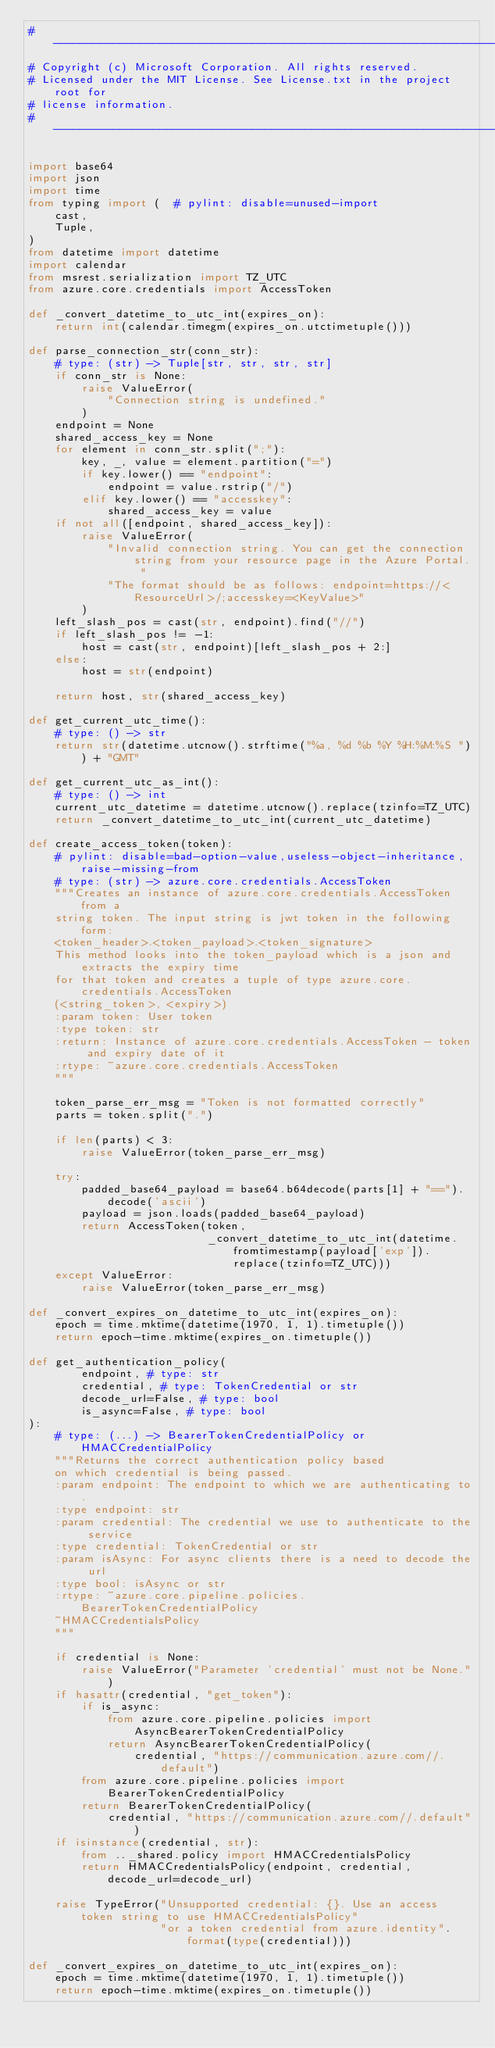Convert code to text. <code><loc_0><loc_0><loc_500><loc_500><_Python_># ------------------------------------------------------------------------
# Copyright (c) Microsoft Corporation. All rights reserved.
# Licensed under the MIT License. See License.txt in the project root for
# license information.
# -------------------------------------------------------------------------

import base64
import json
import time
from typing import (  # pylint: disable=unused-import
    cast,
    Tuple,
)
from datetime import datetime
import calendar
from msrest.serialization import TZ_UTC
from azure.core.credentials import AccessToken

def _convert_datetime_to_utc_int(expires_on):
    return int(calendar.timegm(expires_on.utctimetuple()))

def parse_connection_str(conn_str):
    # type: (str) -> Tuple[str, str, str, str]
    if conn_str is None:
        raise ValueError(
            "Connection string is undefined."
        )
    endpoint = None
    shared_access_key = None
    for element in conn_str.split(";"):
        key, _, value = element.partition("=")
        if key.lower() == "endpoint":
            endpoint = value.rstrip("/")
        elif key.lower() == "accesskey":
            shared_access_key = value
    if not all([endpoint, shared_access_key]):
        raise ValueError(
            "Invalid connection string. You can get the connection string from your resource page in the Azure Portal. "
            "The format should be as follows: endpoint=https://<ResourceUrl>/;accesskey=<KeyValue>"
        )
    left_slash_pos = cast(str, endpoint).find("//")
    if left_slash_pos != -1:
        host = cast(str, endpoint)[left_slash_pos + 2:]
    else:
        host = str(endpoint)

    return host, str(shared_access_key)

def get_current_utc_time():
    # type: () -> str
    return str(datetime.utcnow().strftime("%a, %d %b %Y %H:%M:%S ")) + "GMT"

def get_current_utc_as_int():
    # type: () -> int
    current_utc_datetime = datetime.utcnow().replace(tzinfo=TZ_UTC)
    return _convert_datetime_to_utc_int(current_utc_datetime)

def create_access_token(token):
    # pylint: disable=bad-option-value,useless-object-inheritance,raise-missing-from
    # type: (str) -> azure.core.credentials.AccessToken
    """Creates an instance of azure.core.credentials.AccessToken from a
    string token. The input string is jwt token in the following form:
    <token_header>.<token_payload>.<token_signature>
    This method looks into the token_payload which is a json and extracts the expiry time
    for that token and creates a tuple of type azure.core.credentials.AccessToken
    (<string_token>, <expiry>)
    :param token: User token
    :type token: str
    :return: Instance of azure.core.credentials.AccessToken - token and expiry date of it
    :rtype: ~azure.core.credentials.AccessToken
    """

    token_parse_err_msg = "Token is not formatted correctly"
    parts = token.split(".")

    if len(parts) < 3:
        raise ValueError(token_parse_err_msg)

    try:
        padded_base64_payload = base64.b64decode(parts[1] + "==").decode('ascii')
        payload = json.loads(padded_base64_payload)
        return AccessToken(token,
                           _convert_datetime_to_utc_int(datetime.fromtimestamp(payload['exp']).replace(tzinfo=TZ_UTC)))
    except ValueError:
        raise ValueError(token_parse_err_msg)

def _convert_expires_on_datetime_to_utc_int(expires_on):
    epoch = time.mktime(datetime(1970, 1, 1).timetuple())
    return epoch-time.mktime(expires_on.timetuple())

def get_authentication_policy(
        endpoint, # type: str
        credential, # type: TokenCredential or str
        decode_url=False, # type: bool
        is_async=False, # type: bool
):
    # type: (...) -> BearerTokenCredentialPolicy or HMACCredentialPolicy
    """Returns the correct authentication policy based
    on which credential is being passed.
    :param endpoint: The endpoint to which we are authenticating to.
    :type endpoint: str
    :param credential: The credential we use to authenticate to the service
    :type credential: TokenCredential or str
    :param isAsync: For async clients there is a need to decode the url
    :type bool: isAsync or str
    :rtype: ~azure.core.pipeline.policies.BearerTokenCredentialPolicy
    ~HMACCredentialsPolicy
    """

    if credential is None:
        raise ValueError("Parameter 'credential' must not be None.")
    if hasattr(credential, "get_token"):
        if is_async:
            from azure.core.pipeline.policies import AsyncBearerTokenCredentialPolicy
            return AsyncBearerTokenCredentialPolicy(
                credential, "https://communication.azure.com//.default")
        from azure.core.pipeline.policies import BearerTokenCredentialPolicy
        return BearerTokenCredentialPolicy(
            credential, "https://communication.azure.com//.default")
    if isinstance(credential, str):
        from .._shared.policy import HMACCredentialsPolicy
        return HMACCredentialsPolicy(endpoint, credential, decode_url=decode_url)

    raise TypeError("Unsupported credential: {}. Use an access token string to use HMACCredentialsPolicy"
                    "or a token credential from azure.identity".format(type(credential)))

def _convert_expires_on_datetime_to_utc_int(expires_on):
    epoch = time.mktime(datetime(1970, 1, 1).timetuple())
    return epoch-time.mktime(expires_on.timetuple())
</code> 